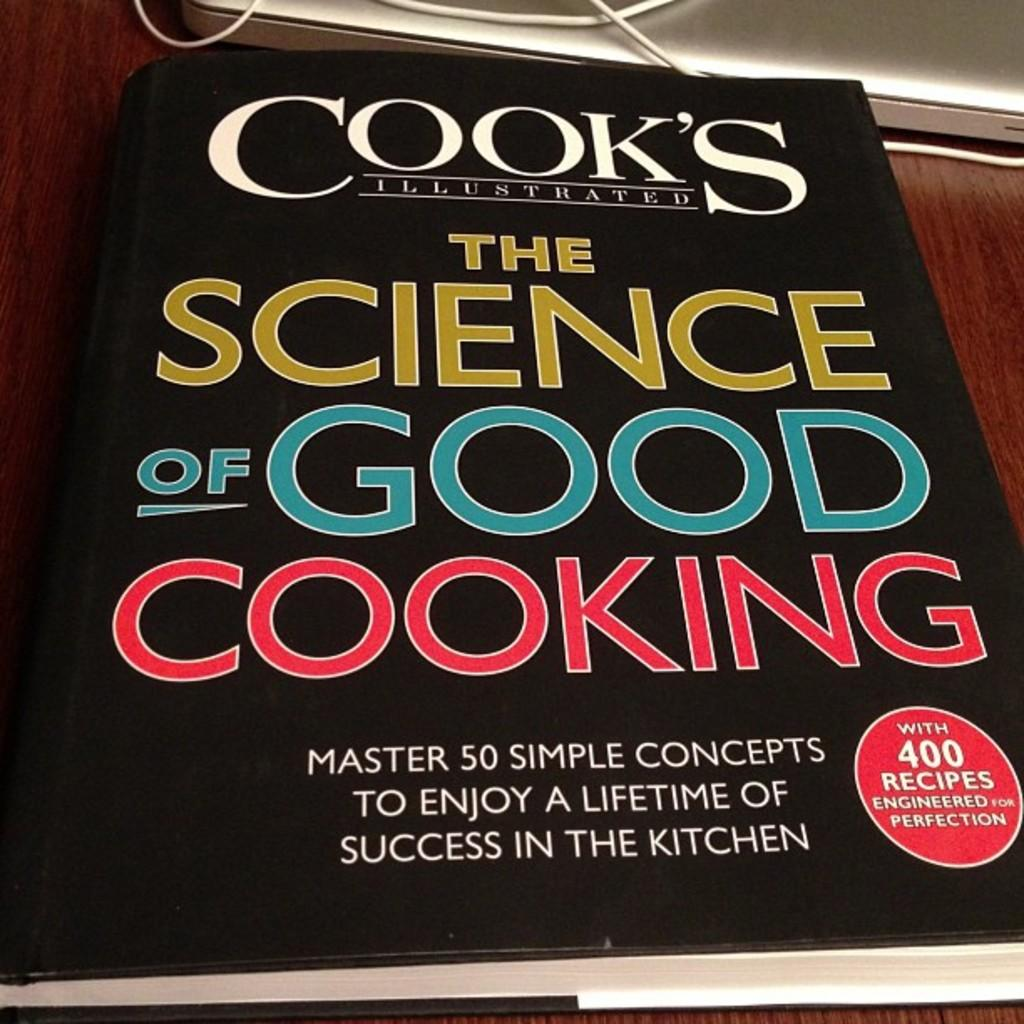Provide a one-sentence caption for the provided image. copy of cook's illustrated the science of good cooking. 